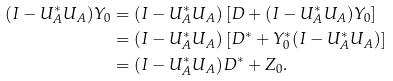Convert formula to latex. <formula><loc_0><loc_0><loc_500><loc_500>( I - U _ { A } ^ { * } U _ { A } ) Y _ { 0 } & = ( I - U _ { A } ^ { * } U _ { A } ) \left [ D + ( I - U _ { A } ^ { * } U _ { A } ) Y _ { 0 } \right ] \\ & = ( I - U _ { A } ^ { * } U _ { A } ) \left [ D ^ { * } + Y _ { 0 } ^ { * } ( I - U _ { A } ^ { * } U _ { A } ) \right ] \\ & = ( I - U _ { A } ^ { * } U _ { A } ) D ^ { * } + Z _ { 0 } .</formula> 